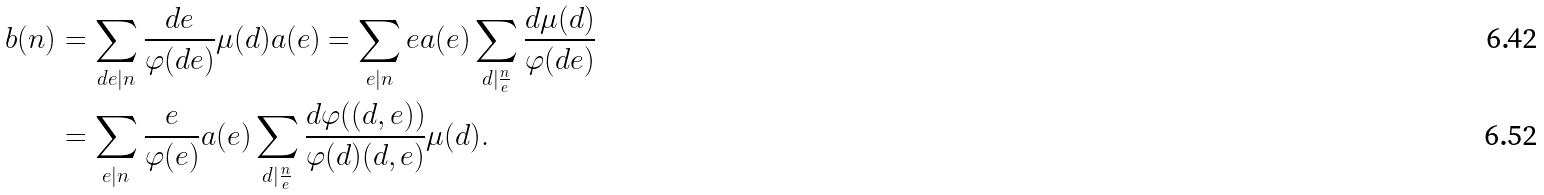<formula> <loc_0><loc_0><loc_500><loc_500>b ( n ) & = \sum _ { d e | n } \frac { d e } { \varphi ( d e ) } \mu ( d ) a ( e ) = \sum _ { e | n } e a ( e ) \sum _ { d | \frac { n } { e } } \frac { d \mu ( d ) } { \varphi ( d e ) } \\ & = \sum _ { e | n } \frac { e } { \varphi ( e ) } a ( e ) \sum _ { d | \frac { n } { e } } \frac { d \varphi ( ( d , e ) ) } { \varphi ( d ) ( d , e ) } \mu ( d ) .</formula> 